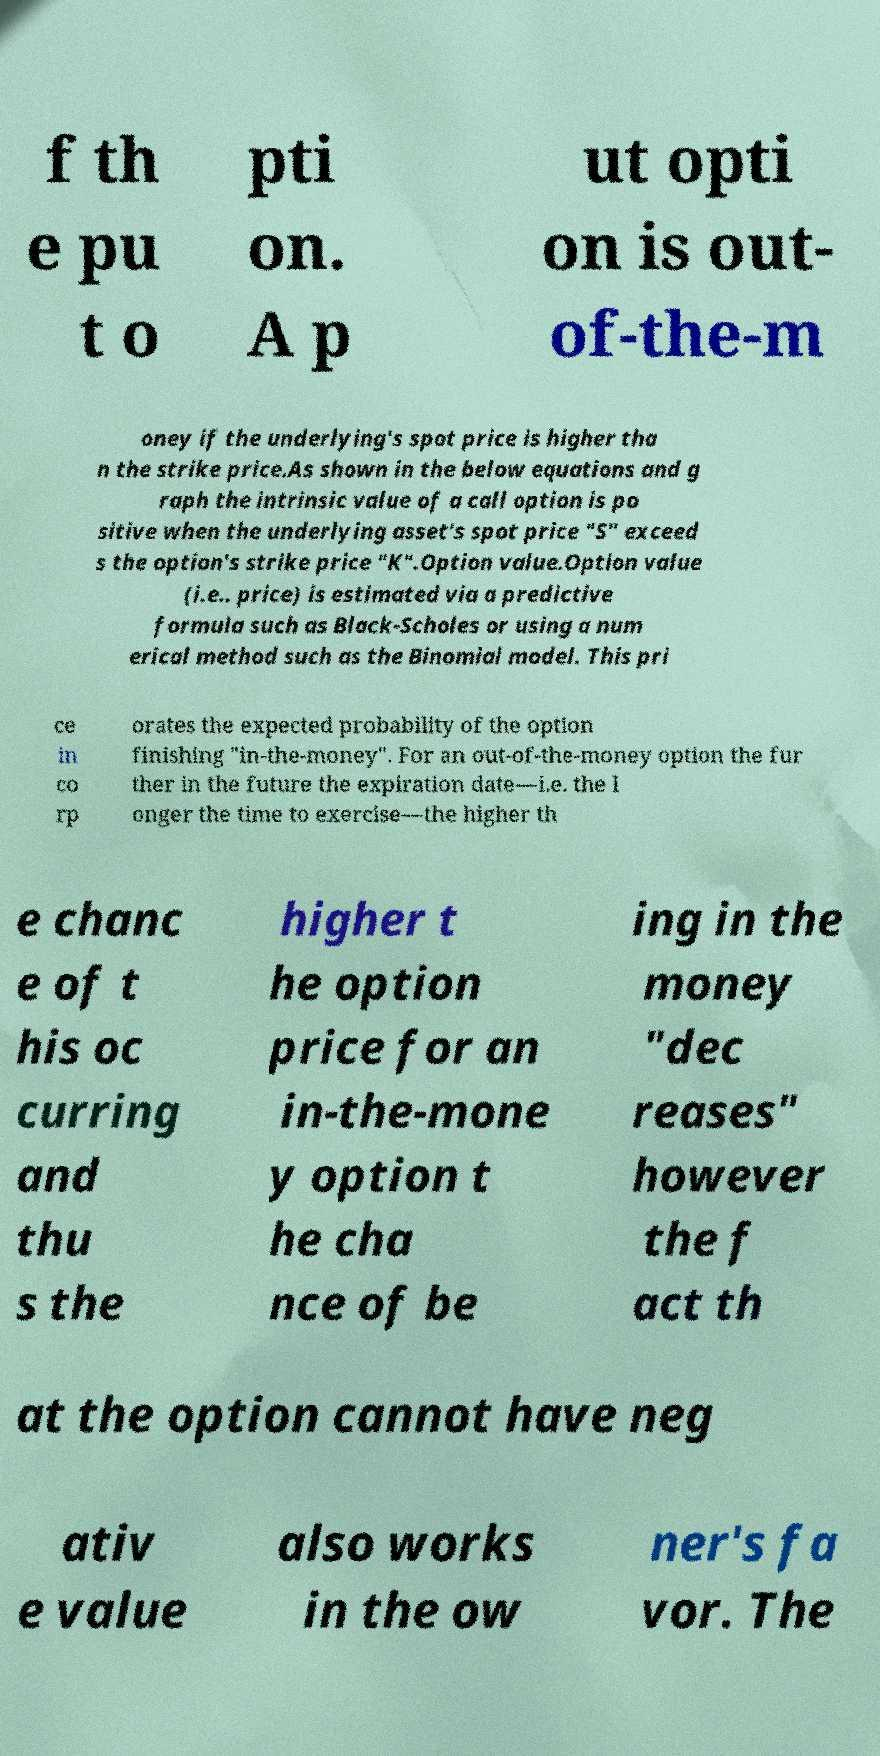Can you read and provide the text displayed in the image?This photo seems to have some interesting text. Can you extract and type it out for me? f th e pu t o pti on. A p ut opti on is out- of-the-m oney if the underlying's spot price is higher tha n the strike price.As shown in the below equations and g raph the intrinsic value of a call option is po sitive when the underlying asset's spot price "S" exceed s the option's strike price "K".Option value.Option value (i.e.. price) is estimated via a predictive formula such as Black-Scholes or using a num erical method such as the Binomial model. This pri ce in co rp orates the expected probability of the option finishing "in-the-money". For an out-of-the-money option the fur ther in the future the expiration date—i.e. the l onger the time to exercise—the higher th e chanc e of t his oc curring and thu s the higher t he option price for an in-the-mone y option t he cha nce of be ing in the money "dec reases" however the f act th at the option cannot have neg ativ e value also works in the ow ner's fa vor. The 